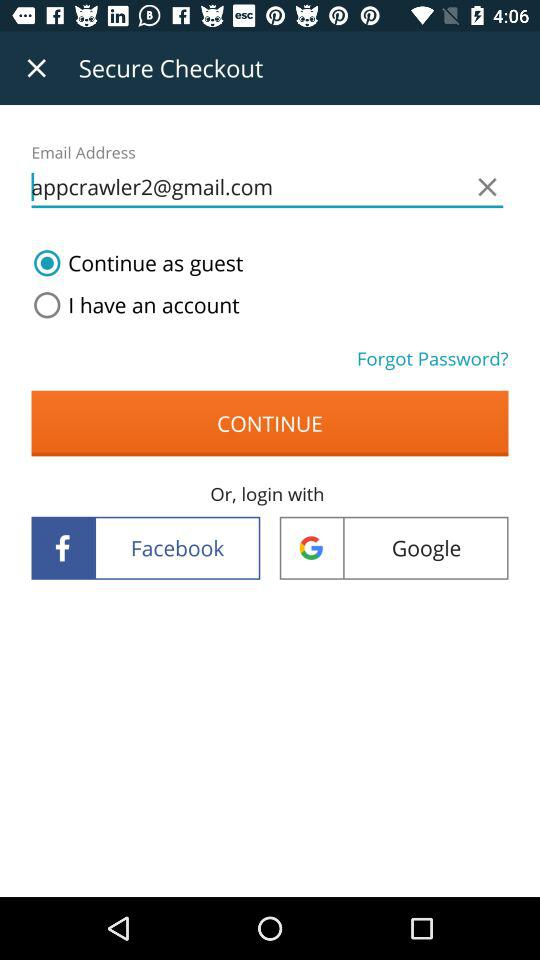Which is the selected option? The selected option is "Continue as guest". 